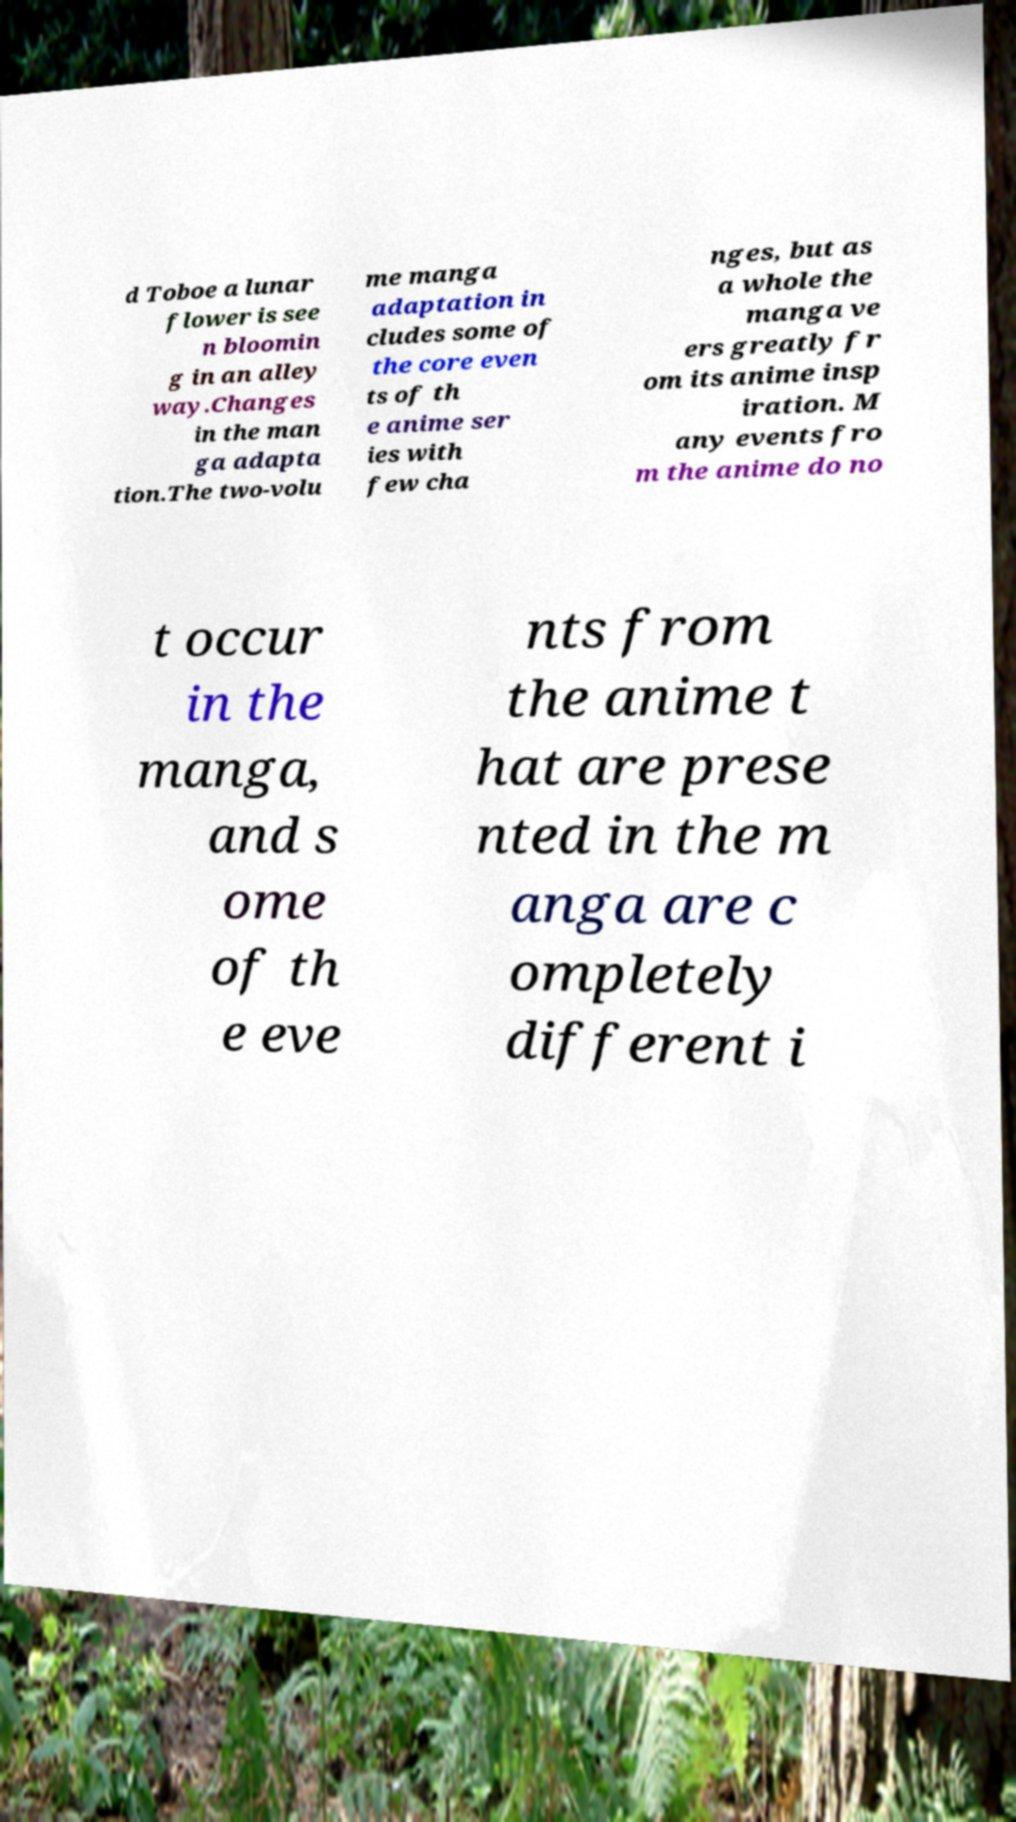Can you accurately transcribe the text from the provided image for me? d Toboe a lunar flower is see n bloomin g in an alley way.Changes in the man ga adapta tion.The two-volu me manga adaptation in cludes some of the core even ts of th e anime ser ies with few cha nges, but as a whole the manga ve ers greatly fr om its anime insp iration. M any events fro m the anime do no t occur in the manga, and s ome of th e eve nts from the anime t hat are prese nted in the m anga are c ompletely different i 